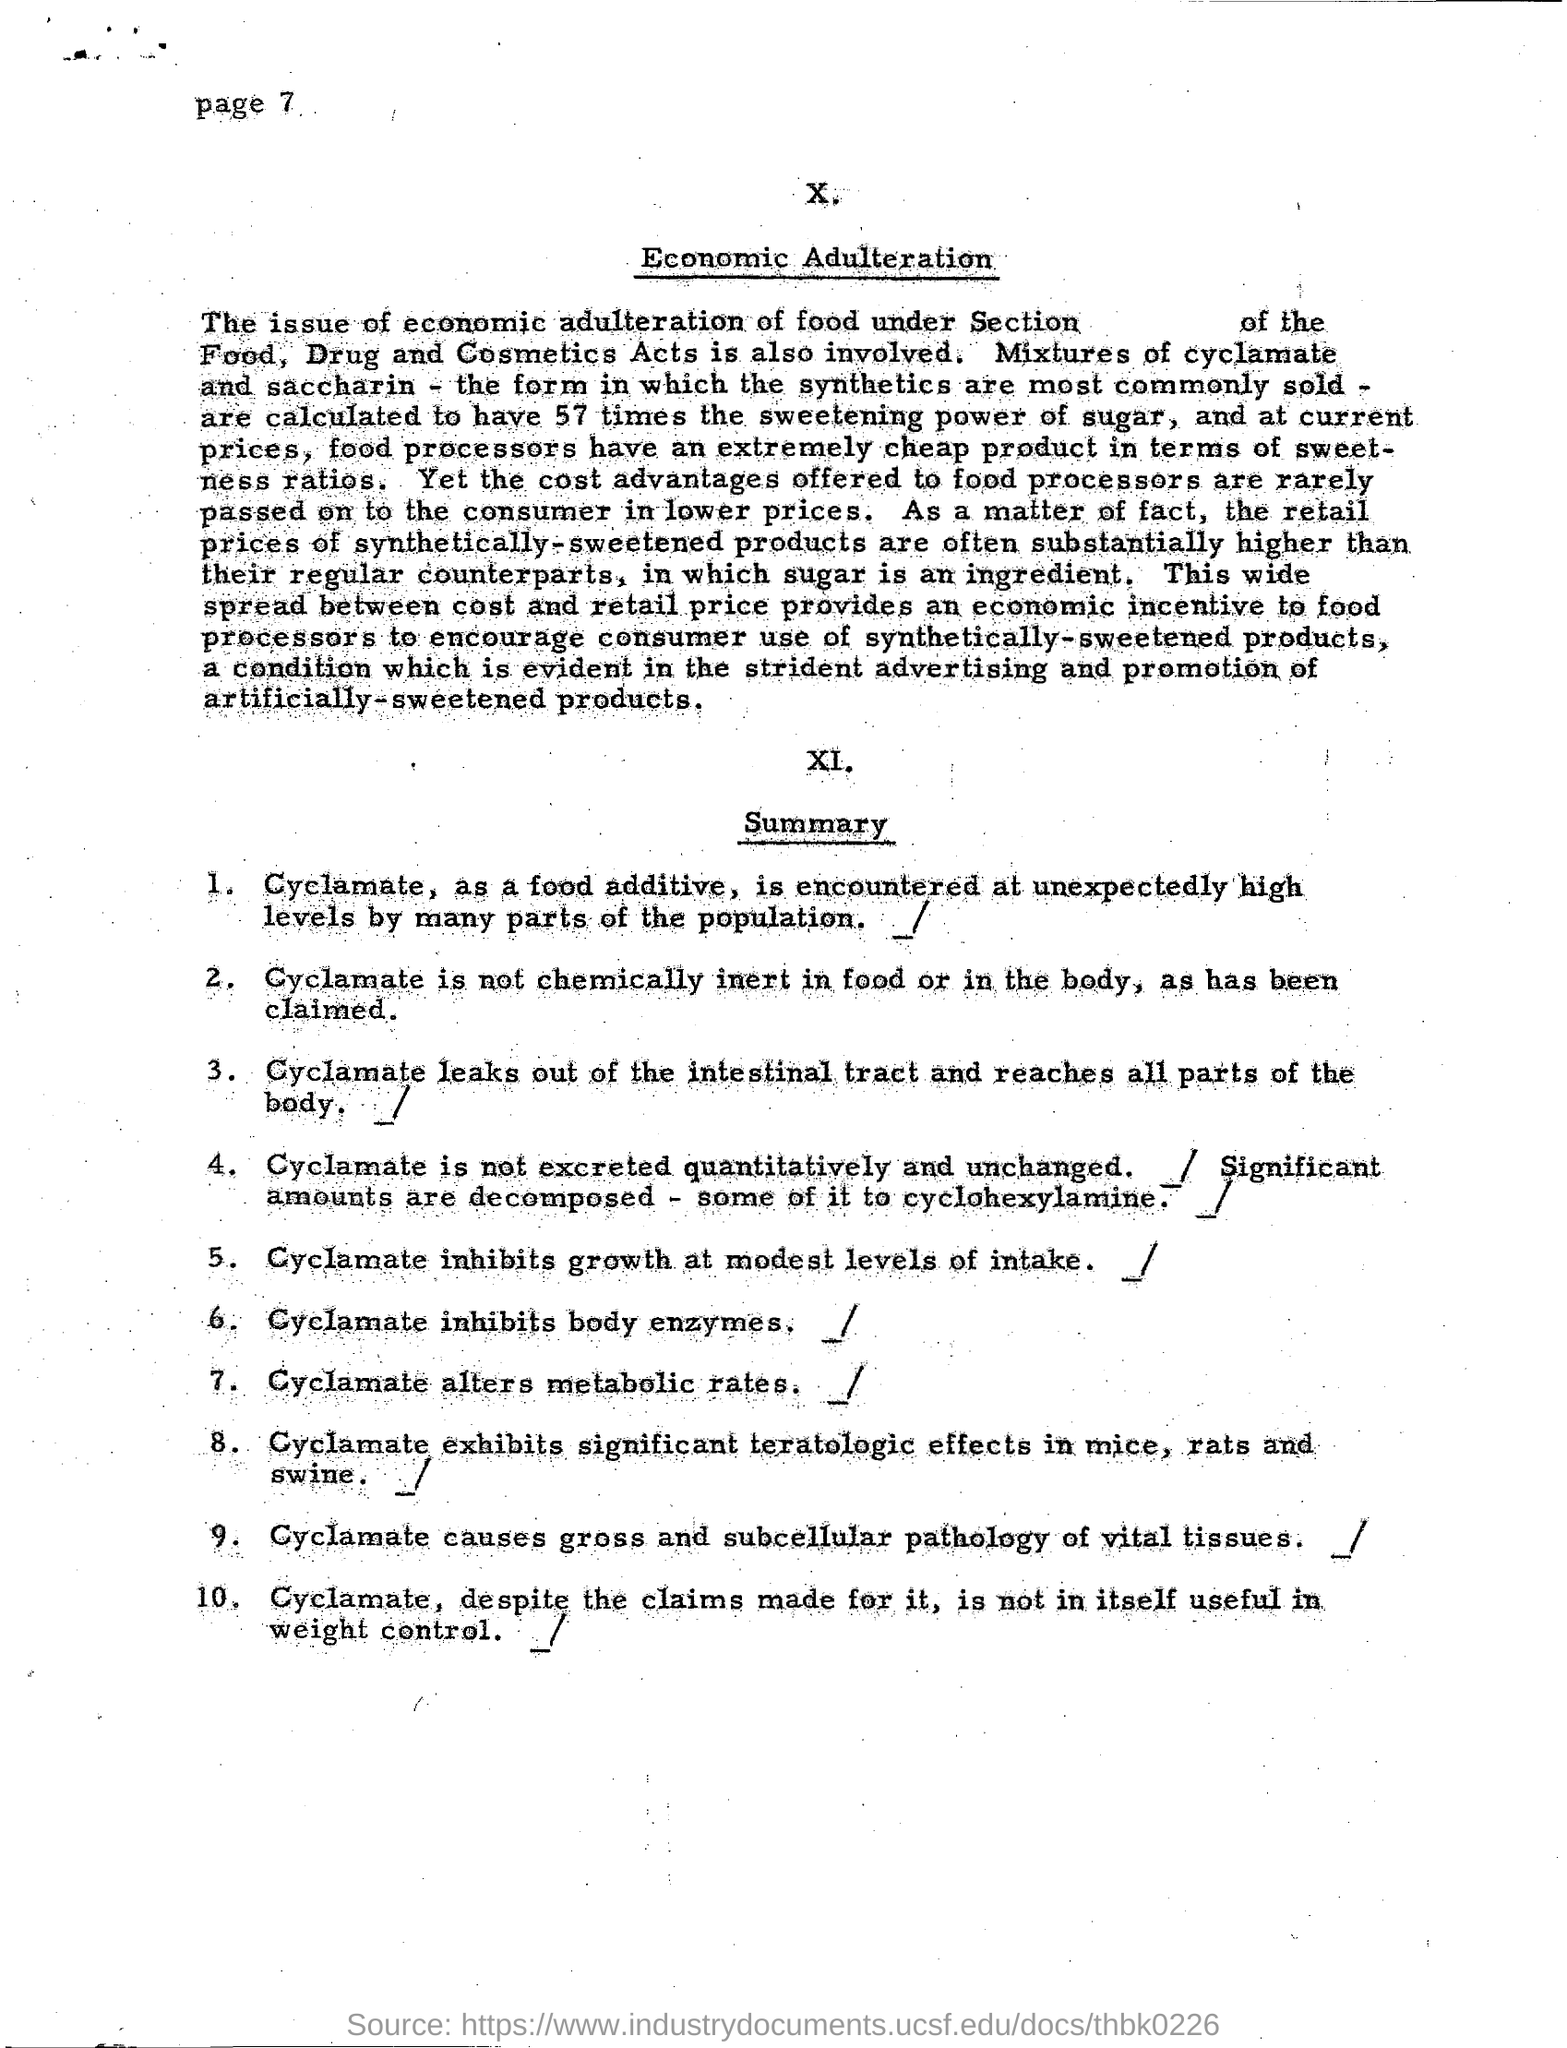Highlight a few significant elements in this photo. Excessive intake of cyclamate can inhibit growth at moderate levels of consumption. Cyclamate inhibits the activity of body enzymes. Many parts of the population have encountered high levels of cyclamate, which is a food additive, unexpectedly. What affects metabolic rates? Cyclamate is one factor that can alter metabolic rates. 